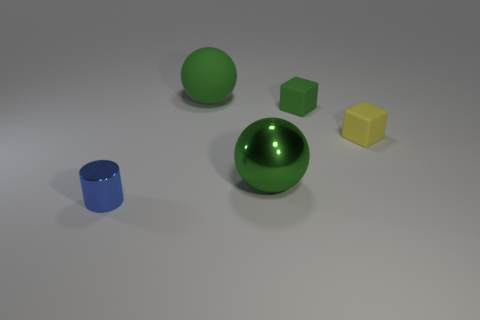Can you describe the color and texture of the cube in the image? The cube in the image has a green color with a matte texture, similar to the large green object to its left. 